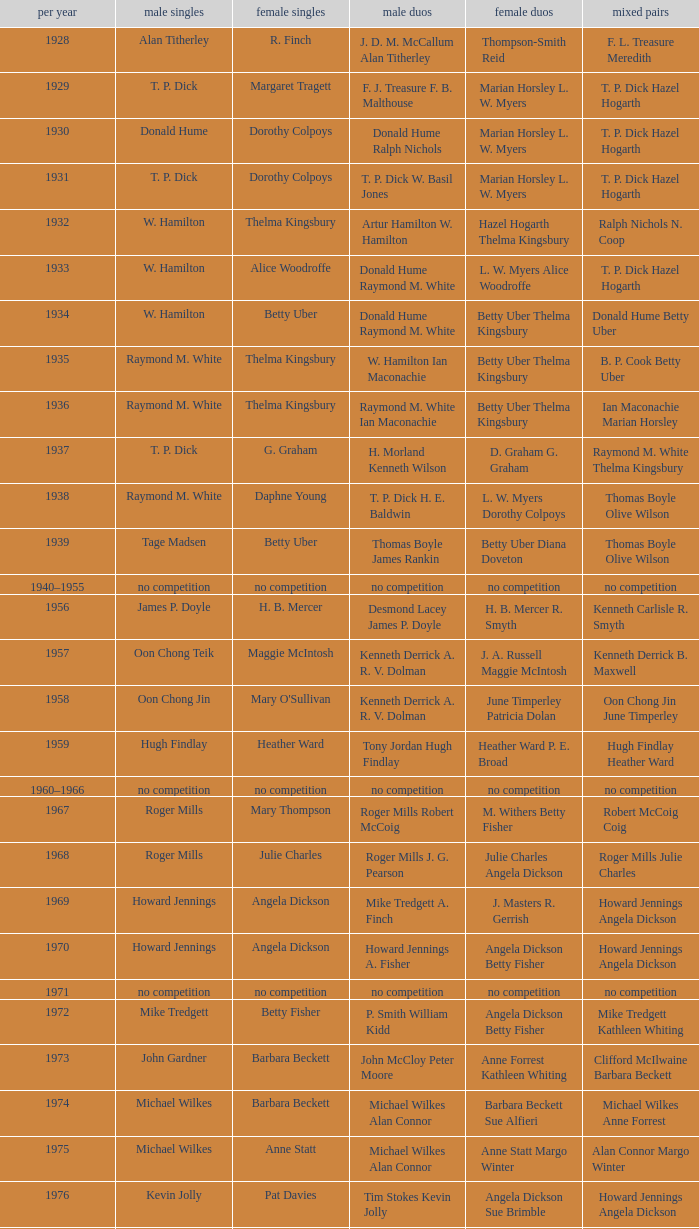Parse the table in full. {'header': ['per year', 'male singles', 'female singles', 'male duos', 'female duos', 'mixed pairs'], 'rows': [['1928', 'Alan Titherley', 'R. Finch', 'J. D. M. McCallum Alan Titherley', 'Thompson-Smith Reid', 'F. L. Treasure Meredith'], ['1929', 'T. P. Dick', 'Margaret Tragett', 'F. J. Treasure F. B. Malthouse', 'Marian Horsley L. W. Myers', 'T. P. Dick Hazel Hogarth'], ['1930', 'Donald Hume', 'Dorothy Colpoys', 'Donald Hume Ralph Nichols', 'Marian Horsley L. W. Myers', 'T. P. Dick Hazel Hogarth'], ['1931', 'T. P. Dick', 'Dorothy Colpoys', 'T. P. Dick W. Basil Jones', 'Marian Horsley L. W. Myers', 'T. P. Dick Hazel Hogarth'], ['1932', 'W. Hamilton', 'Thelma Kingsbury', 'Artur Hamilton W. Hamilton', 'Hazel Hogarth Thelma Kingsbury', 'Ralph Nichols N. Coop'], ['1933', 'W. Hamilton', 'Alice Woodroffe', 'Donald Hume Raymond M. White', 'L. W. Myers Alice Woodroffe', 'T. P. Dick Hazel Hogarth'], ['1934', 'W. Hamilton', 'Betty Uber', 'Donald Hume Raymond M. White', 'Betty Uber Thelma Kingsbury', 'Donald Hume Betty Uber'], ['1935', 'Raymond M. White', 'Thelma Kingsbury', 'W. Hamilton Ian Maconachie', 'Betty Uber Thelma Kingsbury', 'B. P. Cook Betty Uber'], ['1936', 'Raymond M. White', 'Thelma Kingsbury', 'Raymond M. White Ian Maconachie', 'Betty Uber Thelma Kingsbury', 'Ian Maconachie Marian Horsley'], ['1937', 'T. P. Dick', 'G. Graham', 'H. Morland Kenneth Wilson', 'D. Graham G. Graham', 'Raymond M. White Thelma Kingsbury'], ['1938', 'Raymond M. White', 'Daphne Young', 'T. P. Dick H. E. Baldwin', 'L. W. Myers Dorothy Colpoys', 'Thomas Boyle Olive Wilson'], ['1939', 'Tage Madsen', 'Betty Uber', 'Thomas Boyle James Rankin', 'Betty Uber Diana Doveton', 'Thomas Boyle Olive Wilson'], ['1940–1955', 'no competition', 'no competition', 'no competition', 'no competition', 'no competition'], ['1956', 'James P. Doyle', 'H. B. Mercer', 'Desmond Lacey James P. Doyle', 'H. B. Mercer R. Smyth', 'Kenneth Carlisle R. Smyth'], ['1957', 'Oon Chong Teik', 'Maggie McIntosh', 'Kenneth Derrick A. R. V. Dolman', 'J. A. Russell Maggie McIntosh', 'Kenneth Derrick B. Maxwell'], ['1958', 'Oon Chong Jin', "Mary O'Sullivan", 'Kenneth Derrick A. R. V. Dolman', 'June Timperley Patricia Dolan', 'Oon Chong Jin June Timperley'], ['1959', 'Hugh Findlay', 'Heather Ward', 'Tony Jordan Hugh Findlay', 'Heather Ward P. E. Broad', 'Hugh Findlay Heather Ward'], ['1960–1966', 'no competition', 'no competition', 'no competition', 'no competition', 'no competition'], ['1967', 'Roger Mills', 'Mary Thompson', 'Roger Mills Robert McCoig', 'M. Withers Betty Fisher', 'Robert McCoig Coig'], ['1968', 'Roger Mills', 'Julie Charles', 'Roger Mills J. G. Pearson', 'Julie Charles Angela Dickson', 'Roger Mills Julie Charles'], ['1969', 'Howard Jennings', 'Angela Dickson', 'Mike Tredgett A. Finch', 'J. Masters R. Gerrish', 'Howard Jennings Angela Dickson'], ['1970', 'Howard Jennings', 'Angela Dickson', 'Howard Jennings A. Fisher', 'Angela Dickson Betty Fisher', 'Howard Jennings Angela Dickson'], ['1971', 'no competition', 'no competition', 'no competition', 'no competition', 'no competition'], ['1972', 'Mike Tredgett', 'Betty Fisher', 'P. Smith William Kidd', 'Angela Dickson Betty Fisher', 'Mike Tredgett Kathleen Whiting'], ['1973', 'John Gardner', 'Barbara Beckett', 'John McCloy Peter Moore', 'Anne Forrest Kathleen Whiting', 'Clifford McIlwaine Barbara Beckett'], ['1974', 'Michael Wilkes', 'Barbara Beckett', 'Michael Wilkes Alan Connor', 'Barbara Beckett Sue Alfieri', 'Michael Wilkes Anne Forrest'], ['1975', 'Michael Wilkes', 'Anne Statt', 'Michael Wilkes Alan Connor', 'Anne Statt Margo Winter', 'Alan Connor Margo Winter'], ['1976', 'Kevin Jolly', 'Pat Davies', 'Tim Stokes Kevin Jolly', 'Angela Dickson Sue Brimble', 'Howard Jennings Angela Dickson'], ['1977', 'David Eddy', 'Paula Kilvington', 'David Eddy Eddy Sutton', 'Anne Statt Jane Webster', 'David Eddy Barbara Giles'], ['1978', 'Mike Tredgett', 'Gillian Gilks', 'David Eddy Eddy Sutton', 'Barbara Sutton Marjan Ridder', 'Elliot Stuart Gillian Gilks'], ['1979', 'Kevin Jolly', 'Nora Perry', 'Ray Stevens Mike Tredgett', 'Barbara Sutton Nora Perry', 'Mike Tredgett Nora Perry'], ['1980', 'Thomas Kihlström', 'Jane Webster', 'Thomas Kihlström Bengt Fröman', 'Jane Webster Karen Puttick', 'Billy Gilliland Karen Puttick'], ['1981', 'Ray Stevens', 'Gillian Gilks', 'Ray Stevens Mike Tredgett', 'Gillian Gilks Paula Kilvington', 'Mike Tredgett Nora Perry'], ['1982', 'Steve Baddeley', 'Karen Bridge', 'David Eddy Eddy Sutton', 'Karen Chapman Sally Podger', 'Billy Gilliland Karen Chapman'], ['1983', 'Steve Butler', 'Sally Podger', 'Mike Tredgett Dipak Tailor', 'Nora Perry Jane Webster', 'Dipak Tailor Nora Perry'], ['1984', 'Steve Butler', 'Karen Beckman', 'Mike Tredgett Martin Dew', 'Helen Troke Karen Chapman', 'Mike Tredgett Karen Chapman'], ['1985', 'Morten Frost', 'Charlotte Hattens', 'Billy Gilliland Dan Travers', 'Gillian Gilks Helen Troke', 'Martin Dew Gillian Gilks'], ['1986', 'Darren Hall', 'Fiona Elliott', 'Martin Dew Dipak Tailor', 'Karen Beckman Sara Halsall', 'Jesper Knudsen Nettie Nielsen'], ['1987', 'Darren Hall', 'Fiona Elliott', 'Martin Dew Darren Hall', 'Karen Beckman Sara Halsall', 'Martin Dew Gillian Gilks'], ['1988', 'Vimal Kumar', 'Lee Jung-mi', 'Richard Outterside Mike Brown', 'Fiona Elliott Sara Halsall', 'Martin Dew Gillian Gilks'], ['1989', 'Darren Hall', 'Bang Soo-hyun', 'Nick Ponting Dave Wright', 'Karen Beckman Sara Sankey', 'Mike Brown Jillian Wallwork'], ['1990', 'Mathew Smith', 'Joanne Muggeridge', 'Nick Ponting Dave Wright', 'Karen Chapman Sara Sankey', 'Dave Wright Claire Palmer'], ['1991', 'Vimal Kumar', 'Denyse Julien', 'Nick Ponting Dave Wright', 'Cheryl Johnson Julie Bradbury', 'Nick Ponting Joanne Wright'], ['1992', 'Wei Yan', 'Fiona Smith', 'Michael Adams Chris Rees', 'Denyse Julien Doris Piché', 'Andy Goode Joanne Wright'], ['1993', 'Anders Nielsen', 'Sue Louis Lane', 'Nick Ponting Dave Wright', 'Julie Bradbury Sara Sankey', 'Nick Ponting Joanne Wright'], ['1994', 'Darren Hall', 'Marina Andrievskaya', 'Michael Adams Simon Archer', 'Julie Bradbury Joanne Wright', 'Chris Hunt Joanne Wright'], ['1995', 'Peter Rasmussen', 'Denyse Julien', 'Andrei Andropov Nikolai Zuyev', 'Julie Bradbury Joanne Wright', 'Nick Ponting Joanne Wright'], ['1996', 'Colin Haughton', 'Elena Rybkina', 'Andrei Andropov Nikolai Zuyev', 'Elena Rybkina Marina Yakusheva', 'Nikolai Zuyev Marina Yakusheva'], ['1997', 'Chris Bruil', 'Kelly Morgan', 'Ian Pearson James Anderson', 'Nicole van Hooren Brenda Conijn', 'Quinten van Dalm Nicole van Hooren'], ['1998', 'Dicky Palyama', 'Brenda Beenhakker', 'James Anderson Ian Sullivan', 'Sara Sankey Ella Tripp', 'James Anderson Sara Sankey'], ['1999', 'Daniel Eriksson', 'Marina Andrievskaya', 'Joachim Tesche Jean-Philippe Goyette', 'Marina Andrievskaya Catrine Bengtsson', 'Henrik Andersson Marina Andrievskaya'], ['2000', 'Richard Vaughan', 'Marina Yakusheva', 'Joachim Andersson Peter Axelsson', 'Irina Ruslyakova Marina Yakusheva', 'Peter Jeffrey Joanne Davies'], ['2001', 'Irwansyah', 'Brenda Beenhakker', 'Vincent Laigle Svetoslav Stoyanov', 'Sara Sankey Ella Tripp', 'Nikolai Zuyev Marina Yakusheva'], ['2002', 'Irwansyah', 'Karina de Wit', 'Nikolai Zuyev Stanislav Pukhov', 'Ella Tripp Joanne Wright', 'Nikolai Zuyev Marina Yakusheva'], ['2003', 'Irwansyah', 'Ella Karachkova', 'Ashley Thilthorpe Kristian Roebuck', 'Ella Karachkova Anastasia Russkikh', 'Alexandr Russkikh Anastasia Russkikh'], ['2004', 'Nathan Rice', 'Petya Nedelcheva', 'Reuben Gordown Aji Basuki Sindoro', 'Petya Nedelcheva Yuan Wemyss', 'Matthew Hughes Kelly Morgan'], ['2005', 'Chetan Anand', 'Eleanor Cox', 'Andrew Ellis Dean George', 'Hayley Connor Heather Olver', 'Valiyaveetil Diju Jwala Gutta'], ['2006', 'Irwansyah', 'Huang Chia-chi', 'Matthew Hughes Martyn Lewis', 'Natalie Munt Mariana Agathangelou', 'Kristian Roebuck Natalie Munt'], ['2007', 'Marc Zwiebler', 'Jill Pittard', 'Wojciech Szkudlarczyk Adam Cwalina', 'Chloe Magee Bing Huang', 'Wojciech Szkudlarczyk Malgorzata Kurdelska'], ['2008', 'Brice Leverdez', 'Kati Tolmoff', 'Andrew Bowman Martyn Lewis', 'Mariana Agathangelou Jillie Cooper', 'Watson Briggs Jillie Cooper'], ['2009', 'Kristian Nielsen', 'Tatjana Bibik', 'Vitaliy Durkin Alexandr Nikolaenko', 'Valeria Sorokina Nina Vislova', 'Vitaliy Durkin Nina Vislova'], ['2010', 'Pablo Abián', 'Anita Raj Kaur', 'Peter Käsbauer Josche Zurwonne', 'Joanne Quay Swee Ling Anita Raj Kaur', 'Peter Käsbauer Johanna Goliszewski'], ['2011', 'Niluka Karunaratne', 'Nicole Schaller', 'Chris Coles Matthew Nottingham', 'Ng Hui Ern Ng Hui Lin', 'Martin Campbell Ng Hui Lin'], ['2012', 'Chou Tien-chen', 'Chiang Mei-hui', 'Marcus Ellis Paul Van Rietvelde', 'Gabrielle White Lauren Smith', 'Marcus Ellis Gabrielle White']]} Who won the Women's doubles in the year that Billy Gilliland Karen Puttick won the Mixed doubles? Jane Webster Karen Puttick. 